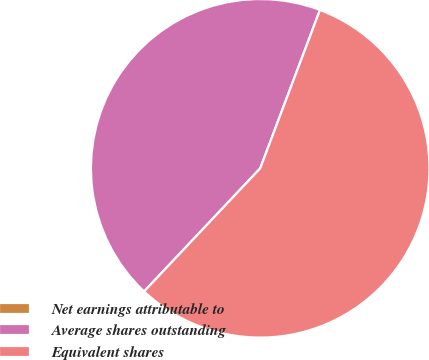Convert chart to OTSL. <chart><loc_0><loc_0><loc_500><loc_500><pie_chart><fcel>Net earnings attributable to<fcel>Average shares outstanding<fcel>Equivalent shares<nl><fcel>0.0%<fcel>43.71%<fcel>56.29%<nl></chart> 